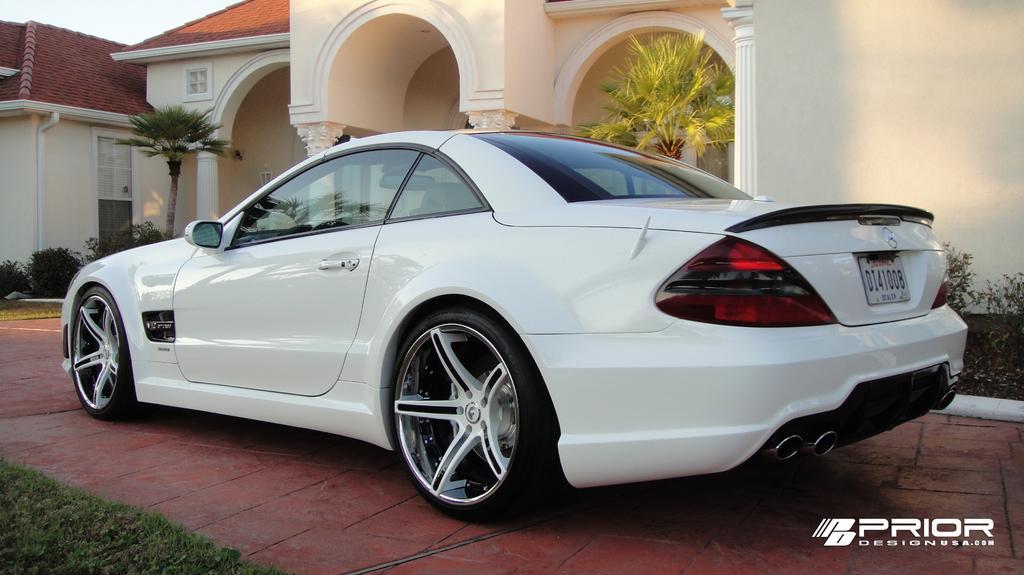How would you summarize this image in a sentence or two? In this image we can see one white car parked near the wall, one big house, one light, one pipe attached to the wall, some trees, bushes, plants and some green grass on the ground. 